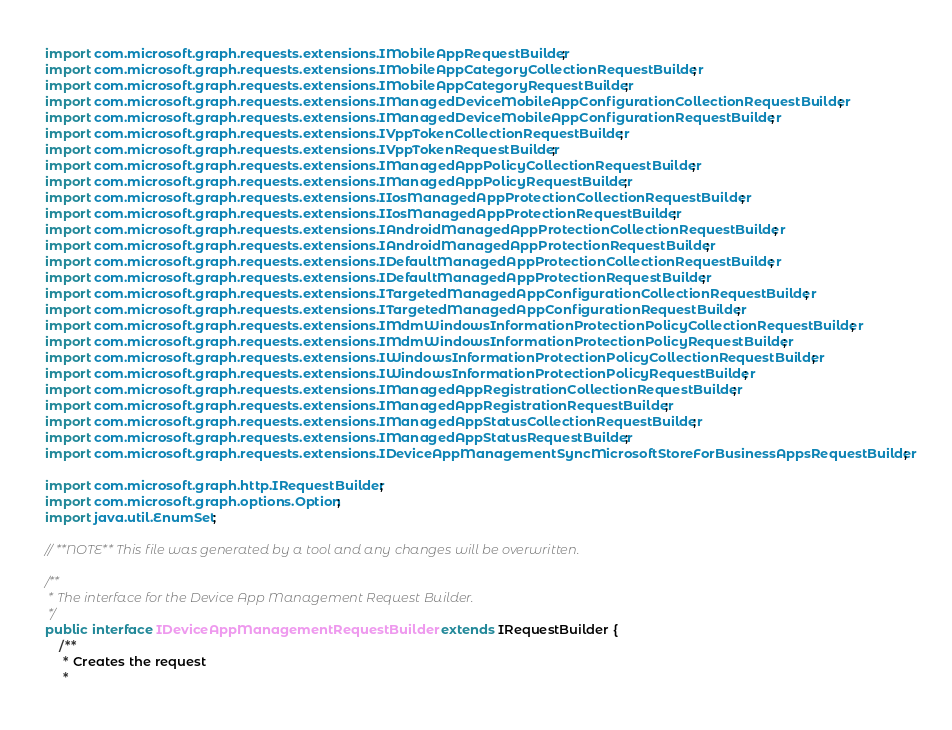<code> <loc_0><loc_0><loc_500><loc_500><_Java_>import com.microsoft.graph.requests.extensions.IMobileAppRequestBuilder;
import com.microsoft.graph.requests.extensions.IMobileAppCategoryCollectionRequestBuilder;
import com.microsoft.graph.requests.extensions.IMobileAppCategoryRequestBuilder;
import com.microsoft.graph.requests.extensions.IManagedDeviceMobileAppConfigurationCollectionRequestBuilder;
import com.microsoft.graph.requests.extensions.IManagedDeviceMobileAppConfigurationRequestBuilder;
import com.microsoft.graph.requests.extensions.IVppTokenCollectionRequestBuilder;
import com.microsoft.graph.requests.extensions.IVppTokenRequestBuilder;
import com.microsoft.graph.requests.extensions.IManagedAppPolicyCollectionRequestBuilder;
import com.microsoft.graph.requests.extensions.IManagedAppPolicyRequestBuilder;
import com.microsoft.graph.requests.extensions.IIosManagedAppProtectionCollectionRequestBuilder;
import com.microsoft.graph.requests.extensions.IIosManagedAppProtectionRequestBuilder;
import com.microsoft.graph.requests.extensions.IAndroidManagedAppProtectionCollectionRequestBuilder;
import com.microsoft.graph.requests.extensions.IAndroidManagedAppProtectionRequestBuilder;
import com.microsoft.graph.requests.extensions.IDefaultManagedAppProtectionCollectionRequestBuilder;
import com.microsoft.graph.requests.extensions.IDefaultManagedAppProtectionRequestBuilder;
import com.microsoft.graph.requests.extensions.ITargetedManagedAppConfigurationCollectionRequestBuilder;
import com.microsoft.graph.requests.extensions.ITargetedManagedAppConfigurationRequestBuilder;
import com.microsoft.graph.requests.extensions.IMdmWindowsInformationProtectionPolicyCollectionRequestBuilder;
import com.microsoft.graph.requests.extensions.IMdmWindowsInformationProtectionPolicyRequestBuilder;
import com.microsoft.graph.requests.extensions.IWindowsInformationProtectionPolicyCollectionRequestBuilder;
import com.microsoft.graph.requests.extensions.IWindowsInformationProtectionPolicyRequestBuilder;
import com.microsoft.graph.requests.extensions.IManagedAppRegistrationCollectionRequestBuilder;
import com.microsoft.graph.requests.extensions.IManagedAppRegistrationRequestBuilder;
import com.microsoft.graph.requests.extensions.IManagedAppStatusCollectionRequestBuilder;
import com.microsoft.graph.requests.extensions.IManagedAppStatusRequestBuilder;
import com.microsoft.graph.requests.extensions.IDeviceAppManagementSyncMicrosoftStoreForBusinessAppsRequestBuilder;

import com.microsoft.graph.http.IRequestBuilder;
import com.microsoft.graph.options.Option;
import java.util.EnumSet;

// **NOTE** This file was generated by a tool and any changes will be overwritten.

/**
 * The interface for the Device App Management Request Builder.
 */
public interface IDeviceAppManagementRequestBuilder extends IRequestBuilder {
    /**
     * Creates the request
     *</code> 